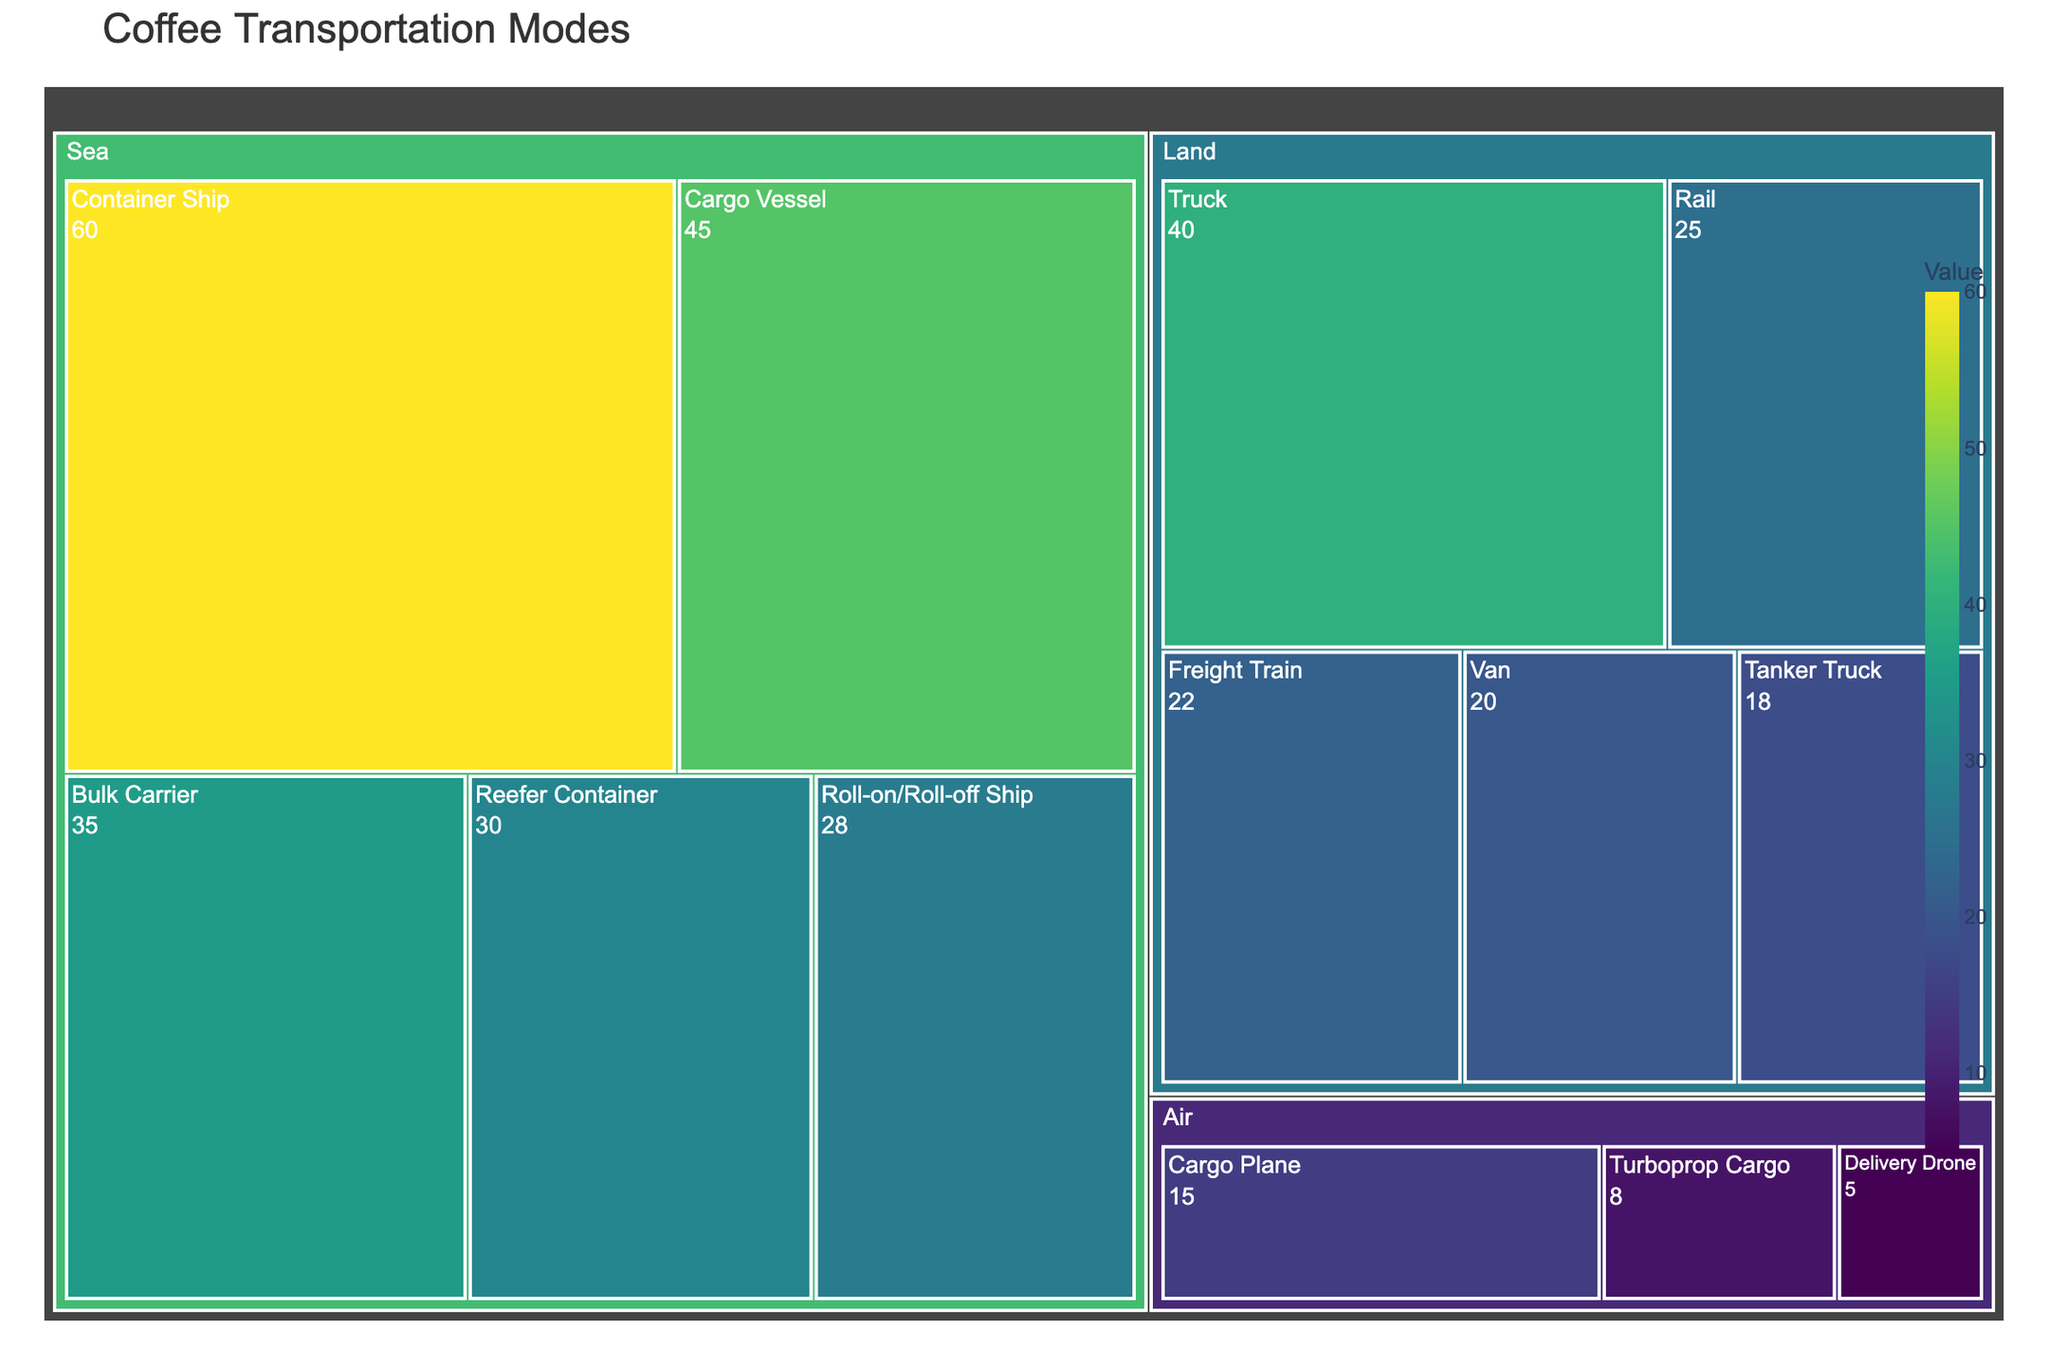What is the title of the treemap? The title is displayed prominently at the top of the treemap.
Answer: Coffee Transportation Modes Which transportation mode has the highest value in the land category? The land category shows several modes like Truck, Rail, Van, and more. The mode with the largest area and value in this category is Truck.
Answer: Truck How many transportation modes are there in the sea category? In the sea category, you can count the different sections: Container Ship, Bulk Carrier, Reefer Container, Cargo Vessel, and Roll-on/Roll-off Ship.
Answer: 5 What is the combined value of all air transportation modes? Add the values of all air transportation modes: Cargo Plane (15) + Delivery Drone (5) + Turboprop Cargo (8).
Answer: 28 Which transportation mode has the smallest value in the sea category? In the sea category, compare the values and find that the Roll-on/Roll-off Ship has the smallest value of 28.
Answer: Roll-on/Roll-off Ship What is the difference in value between the highest and lowest modes in the land category? Highest value in land: Truck (40). Lowest value in land: Tanker Truck (18). Difference: 40 - 18 = 22.
Answer: 22 Which transportation mode in the air category has a value closest to the average value of this category? Average value in air: (15 + 5 + 8) / 3 = 9.33. Closest to 9.33 is Turboprop Cargo with a value of 8.
Answer: Turboprop Cargo What is the sum of the values for Truck and Cargo Plane? Truck (40) + Cargo Plane (15) = 55.
Answer: 55 How does the value of Freight Train compare to Reefer Container? The Freight Train has a value of 22, and the Reefer Container has a value of 30. Therefore, Freight Train has a smaller value.
Answer: Smaller 